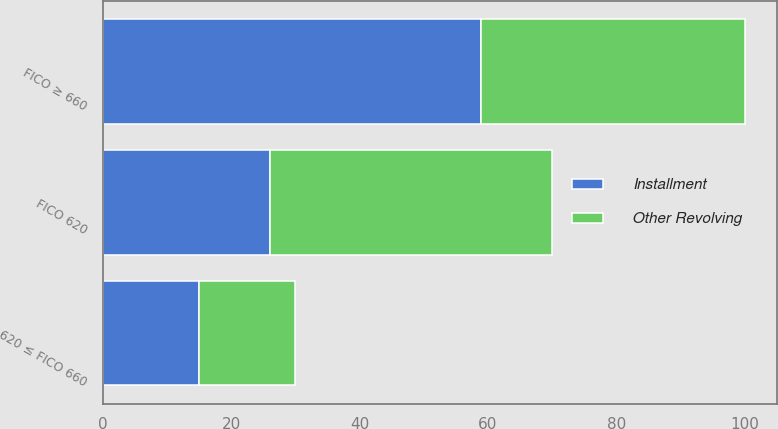Convert chart. <chart><loc_0><loc_0><loc_500><loc_500><stacked_bar_chart><ecel><fcel>FICO ≥ 660<fcel>620 ≤ FICO 660<fcel>FICO 620<nl><fcel>Other Revolving<fcel>41<fcel>15<fcel>44<nl><fcel>Installment<fcel>59<fcel>15<fcel>26<nl></chart> 